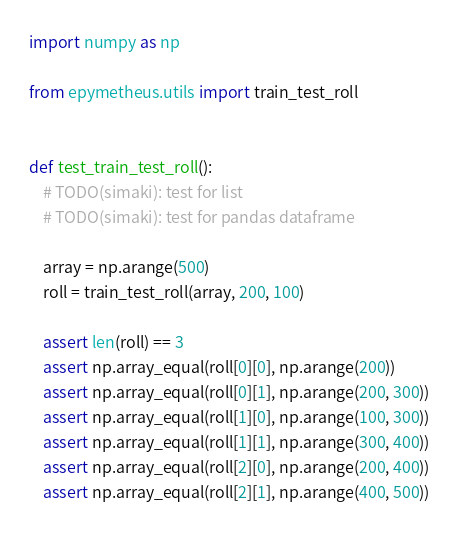<code> <loc_0><loc_0><loc_500><loc_500><_Python_>import numpy as np

from epymetheus.utils import train_test_roll


def test_train_test_roll():
    # TODO(simaki): test for list
    # TODO(simaki): test for pandas dataframe

    array = np.arange(500)
    roll = train_test_roll(array, 200, 100)

    assert len(roll) == 3
    assert np.array_equal(roll[0][0], np.arange(200))
    assert np.array_equal(roll[0][1], np.arange(200, 300))
    assert np.array_equal(roll[1][0], np.arange(100, 300))
    assert np.array_equal(roll[1][1], np.arange(300, 400))
    assert np.array_equal(roll[2][0], np.arange(200, 400))
    assert np.array_equal(roll[2][1], np.arange(400, 500))
</code> 